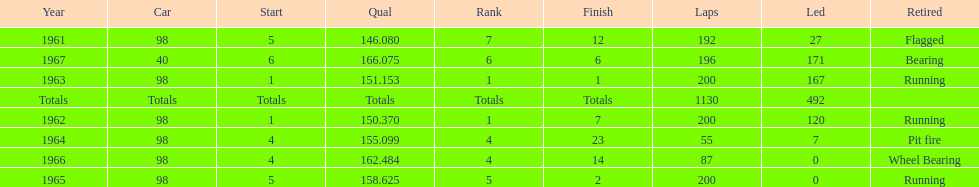What car ranked #1 from 1962-1963? 98. 